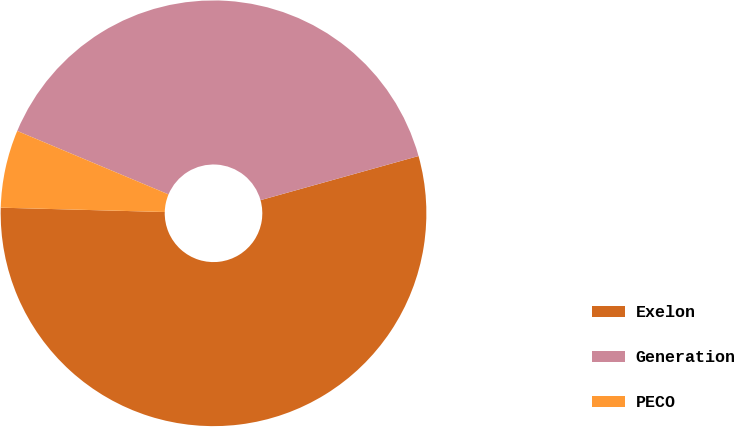Convert chart to OTSL. <chart><loc_0><loc_0><loc_500><loc_500><pie_chart><fcel>Exelon<fcel>Generation<fcel>PECO<nl><fcel>54.75%<fcel>39.34%<fcel>5.9%<nl></chart> 